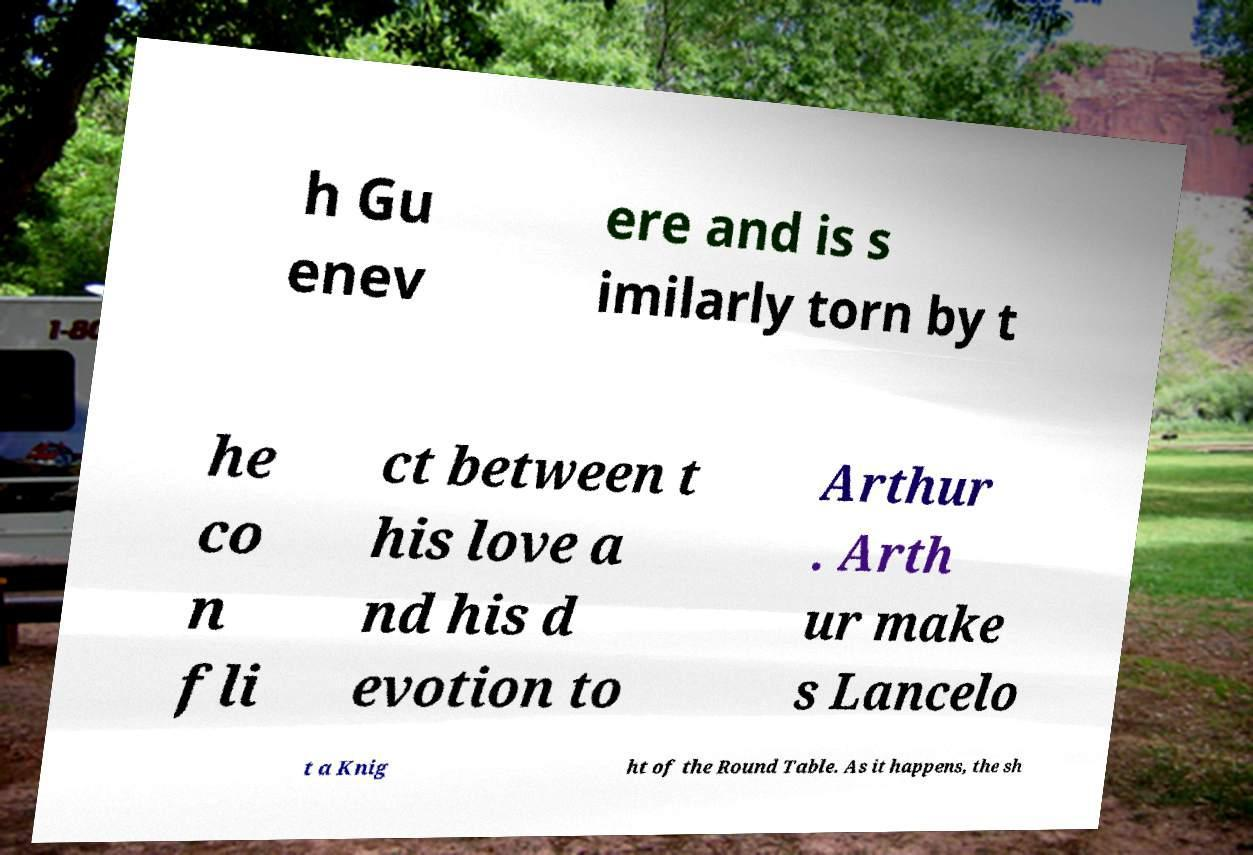Can you read and provide the text displayed in the image?This photo seems to have some interesting text. Can you extract and type it out for me? h Gu enev ere and is s imilarly torn by t he co n fli ct between t his love a nd his d evotion to Arthur . Arth ur make s Lancelo t a Knig ht of the Round Table. As it happens, the sh 